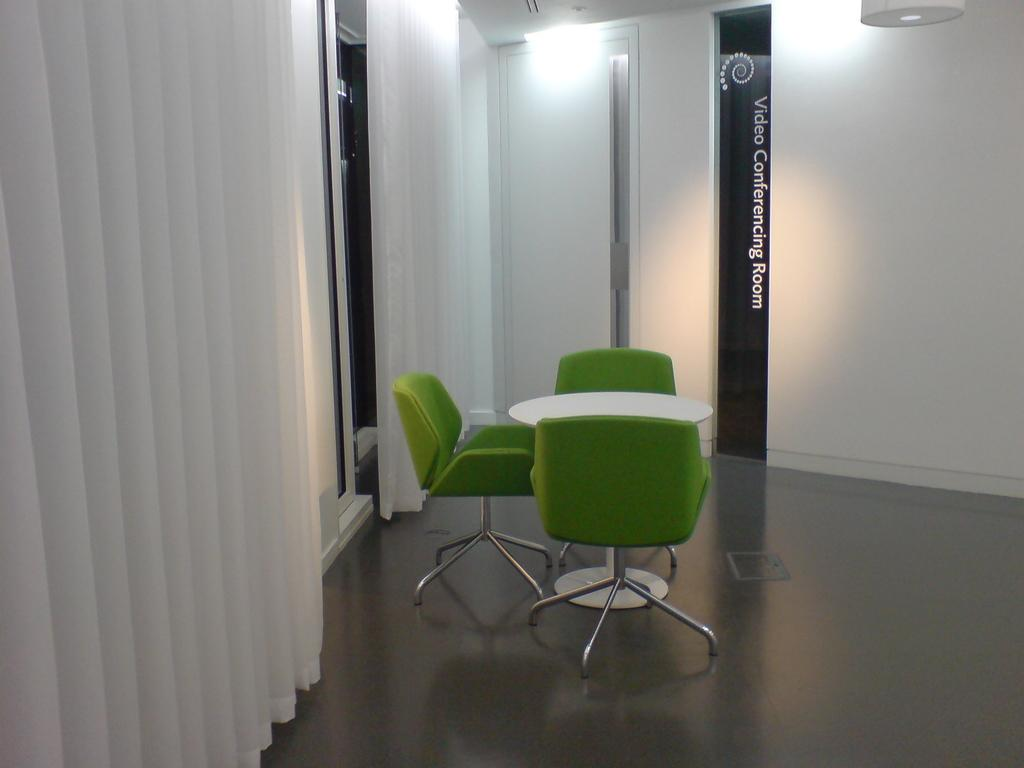What is located in the center of the image? There is a table and chairs in the center of the image. What can be seen in the background of the image? There is a door, curtains, and a wall in the background of the image. How many clovers are on the table in the image? There are no clovers present on the table in the image. What type of comfort can be found in the chairs in the image? The question about comfort is not relevant to the image, as it does not provide information about the chairs' comfort level. 